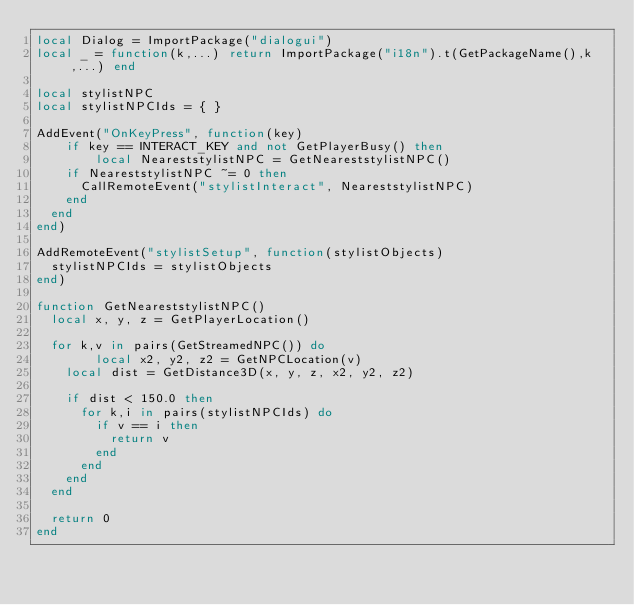Convert code to text. <code><loc_0><loc_0><loc_500><loc_500><_Lua_>local Dialog = ImportPackage("dialogui")
local _ = function(k,...) return ImportPackage("i18n").t(GetPackageName(),k,...) end

local stylistNPC
local stylistNPCIds = { }

AddEvent("OnKeyPress", function(key)
    if key == INTERACT_KEY and not GetPlayerBusy() then
        local NeareststylistNPC = GetNeareststylistNPC()
		if NeareststylistNPC ~= 0 then
			CallRemoteEvent("stylistInteract", NeareststylistNPC)
		end
	end
end)

AddRemoteEvent("stylistSetup", function(stylistObjects)
	stylistNPCIds = stylistObjects
end)

function GetNeareststylistNPC()
	local x, y, z = GetPlayerLocation()
	
	for k,v in pairs(GetStreamedNPC()) do
        local x2, y2, z2 = GetNPCLocation(v)
		local dist = GetDistance3D(x, y, z, x2, y2, z2)

		if dist < 150.0 then
			for k,i in pairs(stylistNPCIds) do
				if v == i then
					return v
				end
			end
		end
	end

	return 0
end
</code> 